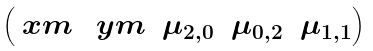Convert formula to latex. <formula><loc_0><loc_0><loc_500><loc_500>\begin{pmatrix} \ x m & \ y m & \mu _ { 2 , 0 } & \mu _ { 0 , 2 } & \mu _ { 1 , 1 } \end{pmatrix}</formula> 